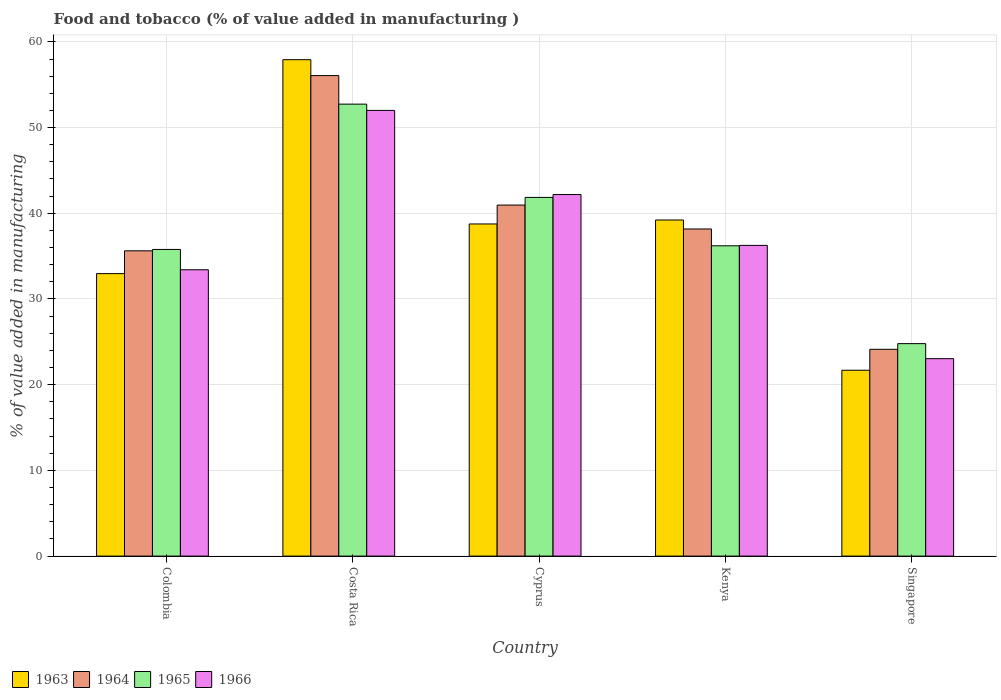How many different coloured bars are there?
Give a very brief answer. 4. Are the number of bars per tick equal to the number of legend labels?
Offer a very short reply. Yes. Are the number of bars on each tick of the X-axis equal?
Your answer should be compact. Yes. How many bars are there on the 1st tick from the left?
Keep it short and to the point. 4. How many bars are there on the 2nd tick from the right?
Ensure brevity in your answer.  4. What is the label of the 5th group of bars from the left?
Your answer should be compact. Singapore. What is the value added in manufacturing food and tobacco in 1965 in Cyprus?
Your response must be concise. 41.85. Across all countries, what is the maximum value added in manufacturing food and tobacco in 1965?
Offer a very short reply. 52.73. Across all countries, what is the minimum value added in manufacturing food and tobacco in 1964?
Ensure brevity in your answer.  24.13. In which country was the value added in manufacturing food and tobacco in 1965 maximum?
Provide a short and direct response. Costa Rica. In which country was the value added in manufacturing food and tobacco in 1965 minimum?
Provide a succinct answer. Singapore. What is the total value added in manufacturing food and tobacco in 1965 in the graph?
Your answer should be very brief. 191.36. What is the difference between the value added in manufacturing food and tobacco in 1964 in Kenya and that in Singapore?
Offer a very short reply. 14.04. What is the difference between the value added in manufacturing food and tobacco in 1964 in Cyprus and the value added in manufacturing food and tobacco in 1963 in Costa Rica?
Ensure brevity in your answer.  -16.96. What is the average value added in manufacturing food and tobacco in 1966 per country?
Ensure brevity in your answer.  37.38. What is the difference between the value added in manufacturing food and tobacco of/in 1965 and value added in manufacturing food and tobacco of/in 1964 in Singapore?
Provide a short and direct response. 0.66. In how many countries, is the value added in manufacturing food and tobacco in 1966 greater than 20 %?
Make the answer very short. 5. What is the ratio of the value added in manufacturing food and tobacco in 1965 in Colombia to that in Singapore?
Provide a short and direct response. 1.44. Is the difference between the value added in manufacturing food and tobacco in 1965 in Costa Rica and Cyprus greater than the difference between the value added in manufacturing food and tobacco in 1964 in Costa Rica and Cyprus?
Your answer should be compact. No. What is the difference between the highest and the second highest value added in manufacturing food and tobacco in 1966?
Make the answer very short. -9.82. What is the difference between the highest and the lowest value added in manufacturing food and tobacco in 1966?
Offer a terse response. 28.97. In how many countries, is the value added in manufacturing food and tobacco in 1963 greater than the average value added in manufacturing food and tobacco in 1963 taken over all countries?
Your answer should be compact. 3. Is the sum of the value added in manufacturing food and tobacco in 1966 in Colombia and Cyprus greater than the maximum value added in manufacturing food and tobacco in 1964 across all countries?
Provide a short and direct response. Yes. What does the 3rd bar from the left in Cyprus represents?
Your answer should be very brief. 1965. What does the 1st bar from the right in Singapore represents?
Your answer should be very brief. 1966. How many bars are there?
Give a very brief answer. 20. How many countries are there in the graph?
Provide a short and direct response. 5. What is the difference between two consecutive major ticks on the Y-axis?
Offer a very short reply. 10. Where does the legend appear in the graph?
Provide a succinct answer. Bottom left. How many legend labels are there?
Your answer should be compact. 4. How are the legend labels stacked?
Give a very brief answer. Horizontal. What is the title of the graph?
Keep it short and to the point. Food and tobacco (% of value added in manufacturing ). Does "2000" appear as one of the legend labels in the graph?
Give a very brief answer. No. What is the label or title of the X-axis?
Your response must be concise. Country. What is the label or title of the Y-axis?
Your answer should be compact. % of value added in manufacturing. What is the % of value added in manufacturing in 1963 in Colombia?
Keep it short and to the point. 32.96. What is the % of value added in manufacturing in 1964 in Colombia?
Make the answer very short. 35.62. What is the % of value added in manufacturing in 1965 in Colombia?
Make the answer very short. 35.78. What is the % of value added in manufacturing of 1966 in Colombia?
Your answer should be compact. 33.41. What is the % of value added in manufacturing of 1963 in Costa Rica?
Your answer should be very brief. 57.92. What is the % of value added in manufacturing in 1964 in Costa Rica?
Your answer should be compact. 56.07. What is the % of value added in manufacturing in 1965 in Costa Rica?
Offer a very short reply. 52.73. What is the % of value added in manufacturing in 1966 in Costa Rica?
Your answer should be very brief. 52. What is the % of value added in manufacturing of 1963 in Cyprus?
Offer a very short reply. 38.75. What is the % of value added in manufacturing of 1964 in Cyprus?
Give a very brief answer. 40.96. What is the % of value added in manufacturing of 1965 in Cyprus?
Offer a very short reply. 41.85. What is the % of value added in manufacturing in 1966 in Cyprus?
Your answer should be very brief. 42.19. What is the % of value added in manufacturing of 1963 in Kenya?
Give a very brief answer. 39.22. What is the % of value added in manufacturing of 1964 in Kenya?
Offer a very short reply. 38.17. What is the % of value added in manufacturing of 1965 in Kenya?
Your answer should be compact. 36.2. What is the % of value added in manufacturing of 1966 in Kenya?
Keep it short and to the point. 36.25. What is the % of value added in manufacturing in 1963 in Singapore?
Provide a short and direct response. 21.69. What is the % of value added in manufacturing in 1964 in Singapore?
Give a very brief answer. 24.13. What is the % of value added in manufacturing of 1965 in Singapore?
Ensure brevity in your answer.  24.79. What is the % of value added in manufacturing in 1966 in Singapore?
Ensure brevity in your answer.  23.04. Across all countries, what is the maximum % of value added in manufacturing of 1963?
Your answer should be very brief. 57.92. Across all countries, what is the maximum % of value added in manufacturing of 1964?
Make the answer very short. 56.07. Across all countries, what is the maximum % of value added in manufacturing of 1965?
Provide a succinct answer. 52.73. Across all countries, what is the maximum % of value added in manufacturing in 1966?
Give a very brief answer. 52. Across all countries, what is the minimum % of value added in manufacturing of 1963?
Your answer should be compact. 21.69. Across all countries, what is the minimum % of value added in manufacturing in 1964?
Ensure brevity in your answer.  24.13. Across all countries, what is the minimum % of value added in manufacturing of 1965?
Your answer should be compact. 24.79. Across all countries, what is the minimum % of value added in manufacturing of 1966?
Give a very brief answer. 23.04. What is the total % of value added in manufacturing in 1963 in the graph?
Make the answer very short. 190.54. What is the total % of value added in manufacturing of 1964 in the graph?
Your response must be concise. 194.94. What is the total % of value added in manufacturing in 1965 in the graph?
Your response must be concise. 191.36. What is the total % of value added in manufacturing of 1966 in the graph?
Give a very brief answer. 186.89. What is the difference between the % of value added in manufacturing in 1963 in Colombia and that in Costa Rica?
Provide a succinct answer. -24.96. What is the difference between the % of value added in manufacturing in 1964 in Colombia and that in Costa Rica?
Offer a terse response. -20.45. What is the difference between the % of value added in manufacturing of 1965 in Colombia and that in Costa Rica?
Your answer should be very brief. -16.95. What is the difference between the % of value added in manufacturing in 1966 in Colombia and that in Costa Rica?
Make the answer very short. -18.59. What is the difference between the % of value added in manufacturing of 1963 in Colombia and that in Cyprus?
Your answer should be very brief. -5.79. What is the difference between the % of value added in manufacturing of 1964 in Colombia and that in Cyprus?
Your response must be concise. -5.34. What is the difference between the % of value added in manufacturing of 1965 in Colombia and that in Cyprus?
Your answer should be compact. -6.07. What is the difference between the % of value added in manufacturing in 1966 in Colombia and that in Cyprus?
Offer a very short reply. -8.78. What is the difference between the % of value added in manufacturing of 1963 in Colombia and that in Kenya?
Keep it short and to the point. -6.26. What is the difference between the % of value added in manufacturing of 1964 in Colombia and that in Kenya?
Provide a short and direct response. -2.55. What is the difference between the % of value added in manufacturing in 1965 in Colombia and that in Kenya?
Provide a short and direct response. -0.42. What is the difference between the % of value added in manufacturing of 1966 in Colombia and that in Kenya?
Ensure brevity in your answer.  -2.84. What is the difference between the % of value added in manufacturing of 1963 in Colombia and that in Singapore?
Offer a very short reply. 11.27. What is the difference between the % of value added in manufacturing of 1964 in Colombia and that in Singapore?
Your answer should be compact. 11.49. What is the difference between the % of value added in manufacturing in 1965 in Colombia and that in Singapore?
Keep it short and to the point. 10.99. What is the difference between the % of value added in manufacturing of 1966 in Colombia and that in Singapore?
Keep it short and to the point. 10.37. What is the difference between the % of value added in manufacturing in 1963 in Costa Rica and that in Cyprus?
Provide a short and direct response. 19.17. What is the difference between the % of value added in manufacturing in 1964 in Costa Rica and that in Cyprus?
Provide a succinct answer. 15.11. What is the difference between the % of value added in manufacturing in 1965 in Costa Rica and that in Cyprus?
Offer a very short reply. 10.88. What is the difference between the % of value added in manufacturing in 1966 in Costa Rica and that in Cyprus?
Your answer should be very brief. 9.82. What is the difference between the % of value added in manufacturing of 1963 in Costa Rica and that in Kenya?
Keep it short and to the point. 18.7. What is the difference between the % of value added in manufacturing in 1964 in Costa Rica and that in Kenya?
Provide a succinct answer. 17.9. What is the difference between the % of value added in manufacturing of 1965 in Costa Rica and that in Kenya?
Provide a short and direct response. 16.53. What is the difference between the % of value added in manufacturing of 1966 in Costa Rica and that in Kenya?
Offer a very short reply. 15.75. What is the difference between the % of value added in manufacturing of 1963 in Costa Rica and that in Singapore?
Provide a short and direct response. 36.23. What is the difference between the % of value added in manufacturing in 1964 in Costa Rica and that in Singapore?
Offer a very short reply. 31.94. What is the difference between the % of value added in manufacturing in 1965 in Costa Rica and that in Singapore?
Your answer should be very brief. 27.94. What is the difference between the % of value added in manufacturing in 1966 in Costa Rica and that in Singapore?
Give a very brief answer. 28.97. What is the difference between the % of value added in manufacturing in 1963 in Cyprus and that in Kenya?
Provide a succinct answer. -0.46. What is the difference between the % of value added in manufacturing in 1964 in Cyprus and that in Kenya?
Ensure brevity in your answer.  2.79. What is the difference between the % of value added in manufacturing in 1965 in Cyprus and that in Kenya?
Ensure brevity in your answer.  5.65. What is the difference between the % of value added in manufacturing of 1966 in Cyprus and that in Kenya?
Provide a succinct answer. 5.93. What is the difference between the % of value added in manufacturing in 1963 in Cyprus and that in Singapore?
Your answer should be very brief. 17.07. What is the difference between the % of value added in manufacturing in 1964 in Cyprus and that in Singapore?
Your response must be concise. 16.83. What is the difference between the % of value added in manufacturing in 1965 in Cyprus and that in Singapore?
Your answer should be compact. 17.06. What is the difference between the % of value added in manufacturing of 1966 in Cyprus and that in Singapore?
Provide a short and direct response. 19.15. What is the difference between the % of value added in manufacturing of 1963 in Kenya and that in Singapore?
Your response must be concise. 17.53. What is the difference between the % of value added in manufacturing in 1964 in Kenya and that in Singapore?
Ensure brevity in your answer.  14.04. What is the difference between the % of value added in manufacturing of 1965 in Kenya and that in Singapore?
Your answer should be very brief. 11.41. What is the difference between the % of value added in manufacturing of 1966 in Kenya and that in Singapore?
Provide a succinct answer. 13.22. What is the difference between the % of value added in manufacturing of 1963 in Colombia and the % of value added in manufacturing of 1964 in Costa Rica?
Your response must be concise. -23.11. What is the difference between the % of value added in manufacturing in 1963 in Colombia and the % of value added in manufacturing in 1965 in Costa Rica?
Make the answer very short. -19.77. What is the difference between the % of value added in manufacturing in 1963 in Colombia and the % of value added in manufacturing in 1966 in Costa Rica?
Keep it short and to the point. -19.04. What is the difference between the % of value added in manufacturing of 1964 in Colombia and the % of value added in manufacturing of 1965 in Costa Rica?
Offer a terse response. -17.11. What is the difference between the % of value added in manufacturing in 1964 in Colombia and the % of value added in manufacturing in 1966 in Costa Rica?
Provide a succinct answer. -16.38. What is the difference between the % of value added in manufacturing of 1965 in Colombia and the % of value added in manufacturing of 1966 in Costa Rica?
Your answer should be compact. -16.22. What is the difference between the % of value added in manufacturing of 1963 in Colombia and the % of value added in manufacturing of 1964 in Cyprus?
Your answer should be very brief. -8. What is the difference between the % of value added in manufacturing in 1963 in Colombia and the % of value added in manufacturing in 1965 in Cyprus?
Your response must be concise. -8.89. What is the difference between the % of value added in manufacturing in 1963 in Colombia and the % of value added in manufacturing in 1966 in Cyprus?
Make the answer very short. -9.23. What is the difference between the % of value added in manufacturing in 1964 in Colombia and the % of value added in manufacturing in 1965 in Cyprus?
Offer a very short reply. -6.23. What is the difference between the % of value added in manufacturing in 1964 in Colombia and the % of value added in manufacturing in 1966 in Cyprus?
Provide a succinct answer. -6.57. What is the difference between the % of value added in manufacturing of 1965 in Colombia and the % of value added in manufacturing of 1966 in Cyprus?
Your answer should be compact. -6.41. What is the difference between the % of value added in manufacturing in 1963 in Colombia and the % of value added in manufacturing in 1964 in Kenya?
Make the answer very short. -5.21. What is the difference between the % of value added in manufacturing of 1963 in Colombia and the % of value added in manufacturing of 1965 in Kenya?
Your answer should be very brief. -3.24. What is the difference between the % of value added in manufacturing of 1963 in Colombia and the % of value added in manufacturing of 1966 in Kenya?
Provide a short and direct response. -3.29. What is the difference between the % of value added in manufacturing of 1964 in Colombia and the % of value added in manufacturing of 1965 in Kenya?
Give a very brief answer. -0.58. What is the difference between the % of value added in manufacturing in 1964 in Colombia and the % of value added in manufacturing in 1966 in Kenya?
Make the answer very short. -0.63. What is the difference between the % of value added in manufacturing of 1965 in Colombia and the % of value added in manufacturing of 1966 in Kenya?
Provide a succinct answer. -0.47. What is the difference between the % of value added in manufacturing of 1963 in Colombia and the % of value added in manufacturing of 1964 in Singapore?
Keep it short and to the point. 8.83. What is the difference between the % of value added in manufacturing of 1963 in Colombia and the % of value added in manufacturing of 1965 in Singapore?
Your response must be concise. 8.17. What is the difference between the % of value added in manufacturing in 1963 in Colombia and the % of value added in manufacturing in 1966 in Singapore?
Give a very brief answer. 9.92. What is the difference between the % of value added in manufacturing of 1964 in Colombia and the % of value added in manufacturing of 1965 in Singapore?
Keep it short and to the point. 10.83. What is the difference between the % of value added in manufacturing of 1964 in Colombia and the % of value added in manufacturing of 1966 in Singapore?
Your answer should be very brief. 12.58. What is the difference between the % of value added in manufacturing in 1965 in Colombia and the % of value added in manufacturing in 1966 in Singapore?
Give a very brief answer. 12.74. What is the difference between the % of value added in manufacturing in 1963 in Costa Rica and the % of value added in manufacturing in 1964 in Cyprus?
Your answer should be very brief. 16.96. What is the difference between the % of value added in manufacturing of 1963 in Costa Rica and the % of value added in manufacturing of 1965 in Cyprus?
Offer a very short reply. 16.07. What is the difference between the % of value added in manufacturing of 1963 in Costa Rica and the % of value added in manufacturing of 1966 in Cyprus?
Your answer should be very brief. 15.73. What is the difference between the % of value added in manufacturing in 1964 in Costa Rica and the % of value added in manufacturing in 1965 in Cyprus?
Give a very brief answer. 14.21. What is the difference between the % of value added in manufacturing of 1964 in Costa Rica and the % of value added in manufacturing of 1966 in Cyprus?
Your answer should be very brief. 13.88. What is the difference between the % of value added in manufacturing of 1965 in Costa Rica and the % of value added in manufacturing of 1966 in Cyprus?
Offer a very short reply. 10.55. What is the difference between the % of value added in manufacturing of 1963 in Costa Rica and the % of value added in manufacturing of 1964 in Kenya?
Offer a terse response. 19.75. What is the difference between the % of value added in manufacturing in 1963 in Costa Rica and the % of value added in manufacturing in 1965 in Kenya?
Make the answer very short. 21.72. What is the difference between the % of value added in manufacturing of 1963 in Costa Rica and the % of value added in manufacturing of 1966 in Kenya?
Offer a terse response. 21.67. What is the difference between the % of value added in manufacturing of 1964 in Costa Rica and the % of value added in manufacturing of 1965 in Kenya?
Offer a very short reply. 19.86. What is the difference between the % of value added in manufacturing of 1964 in Costa Rica and the % of value added in manufacturing of 1966 in Kenya?
Your answer should be very brief. 19.81. What is the difference between the % of value added in manufacturing of 1965 in Costa Rica and the % of value added in manufacturing of 1966 in Kenya?
Your answer should be compact. 16.48. What is the difference between the % of value added in manufacturing in 1963 in Costa Rica and the % of value added in manufacturing in 1964 in Singapore?
Your response must be concise. 33.79. What is the difference between the % of value added in manufacturing in 1963 in Costa Rica and the % of value added in manufacturing in 1965 in Singapore?
Keep it short and to the point. 33.13. What is the difference between the % of value added in manufacturing in 1963 in Costa Rica and the % of value added in manufacturing in 1966 in Singapore?
Keep it short and to the point. 34.88. What is the difference between the % of value added in manufacturing of 1964 in Costa Rica and the % of value added in manufacturing of 1965 in Singapore?
Provide a short and direct response. 31.28. What is the difference between the % of value added in manufacturing of 1964 in Costa Rica and the % of value added in manufacturing of 1966 in Singapore?
Offer a terse response. 33.03. What is the difference between the % of value added in manufacturing in 1965 in Costa Rica and the % of value added in manufacturing in 1966 in Singapore?
Your response must be concise. 29.7. What is the difference between the % of value added in manufacturing of 1963 in Cyprus and the % of value added in manufacturing of 1964 in Kenya?
Your answer should be very brief. 0.59. What is the difference between the % of value added in manufacturing of 1963 in Cyprus and the % of value added in manufacturing of 1965 in Kenya?
Ensure brevity in your answer.  2.55. What is the difference between the % of value added in manufacturing of 1963 in Cyprus and the % of value added in manufacturing of 1966 in Kenya?
Your response must be concise. 2.5. What is the difference between the % of value added in manufacturing of 1964 in Cyprus and the % of value added in manufacturing of 1965 in Kenya?
Keep it short and to the point. 4.75. What is the difference between the % of value added in manufacturing in 1964 in Cyprus and the % of value added in manufacturing in 1966 in Kenya?
Your response must be concise. 4.7. What is the difference between the % of value added in manufacturing of 1965 in Cyprus and the % of value added in manufacturing of 1966 in Kenya?
Keep it short and to the point. 5.6. What is the difference between the % of value added in manufacturing of 1963 in Cyprus and the % of value added in manufacturing of 1964 in Singapore?
Provide a succinct answer. 14.63. What is the difference between the % of value added in manufacturing in 1963 in Cyprus and the % of value added in manufacturing in 1965 in Singapore?
Provide a short and direct response. 13.96. What is the difference between the % of value added in manufacturing in 1963 in Cyprus and the % of value added in manufacturing in 1966 in Singapore?
Offer a very short reply. 15.72. What is the difference between the % of value added in manufacturing in 1964 in Cyprus and the % of value added in manufacturing in 1965 in Singapore?
Provide a short and direct response. 16.17. What is the difference between the % of value added in manufacturing of 1964 in Cyprus and the % of value added in manufacturing of 1966 in Singapore?
Give a very brief answer. 17.92. What is the difference between the % of value added in manufacturing in 1965 in Cyprus and the % of value added in manufacturing in 1966 in Singapore?
Your answer should be very brief. 18.82. What is the difference between the % of value added in manufacturing of 1963 in Kenya and the % of value added in manufacturing of 1964 in Singapore?
Keep it short and to the point. 15.09. What is the difference between the % of value added in manufacturing of 1963 in Kenya and the % of value added in manufacturing of 1965 in Singapore?
Ensure brevity in your answer.  14.43. What is the difference between the % of value added in manufacturing of 1963 in Kenya and the % of value added in manufacturing of 1966 in Singapore?
Provide a succinct answer. 16.18. What is the difference between the % of value added in manufacturing of 1964 in Kenya and the % of value added in manufacturing of 1965 in Singapore?
Your response must be concise. 13.38. What is the difference between the % of value added in manufacturing in 1964 in Kenya and the % of value added in manufacturing in 1966 in Singapore?
Offer a very short reply. 15.13. What is the difference between the % of value added in manufacturing in 1965 in Kenya and the % of value added in manufacturing in 1966 in Singapore?
Make the answer very short. 13.17. What is the average % of value added in manufacturing in 1963 per country?
Your answer should be very brief. 38.11. What is the average % of value added in manufacturing in 1964 per country?
Your answer should be very brief. 38.99. What is the average % of value added in manufacturing in 1965 per country?
Offer a very short reply. 38.27. What is the average % of value added in manufacturing in 1966 per country?
Offer a terse response. 37.38. What is the difference between the % of value added in manufacturing in 1963 and % of value added in manufacturing in 1964 in Colombia?
Offer a terse response. -2.66. What is the difference between the % of value added in manufacturing in 1963 and % of value added in manufacturing in 1965 in Colombia?
Offer a terse response. -2.82. What is the difference between the % of value added in manufacturing of 1963 and % of value added in manufacturing of 1966 in Colombia?
Make the answer very short. -0.45. What is the difference between the % of value added in manufacturing in 1964 and % of value added in manufacturing in 1965 in Colombia?
Offer a very short reply. -0.16. What is the difference between the % of value added in manufacturing of 1964 and % of value added in manufacturing of 1966 in Colombia?
Offer a terse response. 2.21. What is the difference between the % of value added in manufacturing in 1965 and % of value added in manufacturing in 1966 in Colombia?
Your answer should be very brief. 2.37. What is the difference between the % of value added in manufacturing in 1963 and % of value added in manufacturing in 1964 in Costa Rica?
Make the answer very short. 1.85. What is the difference between the % of value added in manufacturing of 1963 and % of value added in manufacturing of 1965 in Costa Rica?
Offer a very short reply. 5.19. What is the difference between the % of value added in manufacturing of 1963 and % of value added in manufacturing of 1966 in Costa Rica?
Ensure brevity in your answer.  5.92. What is the difference between the % of value added in manufacturing in 1964 and % of value added in manufacturing in 1965 in Costa Rica?
Keep it short and to the point. 3.33. What is the difference between the % of value added in manufacturing of 1964 and % of value added in manufacturing of 1966 in Costa Rica?
Provide a short and direct response. 4.06. What is the difference between the % of value added in manufacturing in 1965 and % of value added in manufacturing in 1966 in Costa Rica?
Provide a short and direct response. 0.73. What is the difference between the % of value added in manufacturing in 1963 and % of value added in manufacturing in 1964 in Cyprus?
Give a very brief answer. -2.2. What is the difference between the % of value added in manufacturing in 1963 and % of value added in manufacturing in 1965 in Cyprus?
Keep it short and to the point. -3.1. What is the difference between the % of value added in manufacturing in 1963 and % of value added in manufacturing in 1966 in Cyprus?
Make the answer very short. -3.43. What is the difference between the % of value added in manufacturing in 1964 and % of value added in manufacturing in 1965 in Cyprus?
Your response must be concise. -0.9. What is the difference between the % of value added in manufacturing in 1964 and % of value added in manufacturing in 1966 in Cyprus?
Your answer should be compact. -1.23. What is the difference between the % of value added in manufacturing of 1965 and % of value added in manufacturing of 1966 in Cyprus?
Your answer should be very brief. -0.33. What is the difference between the % of value added in manufacturing in 1963 and % of value added in manufacturing in 1964 in Kenya?
Provide a succinct answer. 1.05. What is the difference between the % of value added in manufacturing in 1963 and % of value added in manufacturing in 1965 in Kenya?
Your answer should be compact. 3.01. What is the difference between the % of value added in manufacturing of 1963 and % of value added in manufacturing of 1966 in Kenya?
Your response must be concise. 2.96. What is the difference between the % of value added in manufacturing in 1964 and % of value added in manufacturing in 1965 in Kenya?
Keep it short and to the point. 1.96. What is the difference between the % of value added in manufacturing of 1964 and % of value added in manufacturing of 1966 in Kenya?
Keep it short and to the point. 1.91. What is the difference between the % of value added in manufacturing of 1965 and % of value added in manufacturing of 1966 in Kenya?
Offer a terse response. -0.05. What is the difference between the % of value added in manufacturing in 1963 and % of value added in manufacturing in 1964 in Singapore?
Offer a terse response. -2.44. What is the difference between the % of value added in manufacturing in 1963 and % of value added in manufacturing in 1965 in Singapore?
Offer a terse response. -3.1. What is the difference between the % of value added in manufacturing of 1963 and % of value added in manufacturing of 1966 in Singapore?
Your answer should be very brief. -1.35. What is the difference between the % of value added in manufacturing of 1964 and % of value added in manufacturing of 1965 in Singapore?
Keep it short and to the point. -0.66. What is the difference between the % of value added in manufacturing of 1964 and % of value added in manufacturing of 1966 in Singapore?
Provide a succinct answer. 1.09. What is the difference between the % of value added in manufacturing in 1965 and % of value added in manufacturing in 1966 in Singapore?
Offer a terse response. 1.75. What is the ratio of the % of value added in manufacturing of 1963 in Colombia to that in Costa Rica?
Your answer should be very brief. 0.57. What is the ratio of the % of value added in manufacturing of 1964 in Colombia to that in Costa Rica?
Make the answer very short. 0.64. What is the ratio of the % of value added in manufacturing of 1965 in Colombia to that in Costa Rica?
Offer a terse response. 0.68. What is the ratio of the % of value added in manufacturing in 1966 in Colombia to that in Costa Rica?
Make the answer very short. 0.64. What is the ratio of the % of value added in manufacturing in 1963 in Colombia to that in Cyprus?
Ensure brevity in your answer.  0.85. What is the ratio of the % of value added in manufacturing in 1964 in Colombia to that in Cyprus?
Ensure brevity in your answer.  0.87. What is the ratio of the % of value added in manufacturing in 1965 in Colombia to that in Cyprus?
Provide a succinct answer. 0.85. What is the ratio of the % of value added in manufacturing in 1966 in Colombia to that in Cyprus?
Offer a very short reply. 0.79. What is the ratio of the % of value added in manufacturing of 1963 in Colombia to that in Kenya?
Provide a succinct answer. 0.84. What is the ratio of the % of value added in manufacturing in 1964 in Colombia to that in Kenya?
Provide a short and direct response. 0.93. What is the ratio of the % of value added in manufacturing in 1965 in Colombia to that in Kenya?
Your response must be concise. 0.99. What is the ratio of the % of value added in manufacturing of 1966 in Colombia to that in Kenya?
Provide a succinct answer. 0.92. What is the ratio of the % of value added in manufacturing in 1963 in Colombia to that in Singapore?
Provide a short and direct response. 1.52. What is the ratio of the % of value added in manufacturing of 1964 in Colombia to that in Singapore?
Ensure brevity in your answer.  1.48. What is the ratio of the % of value added in manufacturing in 1965 in Colombia to that in Singapore?
Offer a terse response. 1.44. What is the ratio of the % of value added in manufacturing in 1966 in Colombia to that in Singapore?
Offer a very short reply. 1.45. What is the ratio of the % of value added in manufacturing of 1963 in Costa Rica to that in Cyprus?
Ensure brevity in your answer.  1.49. What is the ratio of the % of value added in manufacturing in 1964 in Costa Rica to that in Cyprus?
Provide a succinct answer. 1.37. What is the ratio of the % of value added in manufacturing of 1965 in Costa Rica to that in Cyprus?
Make the answer very short. 1.26. What is the ratio of the % of value added in manufacturing of 1966 in Costa Rica to that in Cyprus?
Make the answer very short. 1.23. What is the ratio of the % of value added in manufacturing of 1963 in Costa Rica to that in Kenya?
Offer a very short reply. 1.48. What is the ratio of the % of value added in manufacturing in 1964 in Costa Rica to that in Kenya?
Your answer should be very brief. 1.47. What is the ratio of the % of value added in manufacturing in 1965 in Costa Rica to that in Kenya?
Give a very brief answer. 1.46. What is the ratio of the % of value added in manufacturing in 1966 in Costa Rica to that in Kenya?
Offer a terse response. 1.43. What is the ratio of the % of value added in manufacturing in 1963 in Costa Rica to that in Singapore?
Make the answer very short. 2.67. What is the ratio of the % of value added in manufacturing of 1964 in Costa Rica to that in Singapore?
Make the answer very short. 2.32. What is the ratio of the % of value added in manufacturing in 1965 in Costa Rica to that in Singapore?
Offer a terse response. 2.13. What is the ratio of the % of value added in manufacturing in 1966 in Costa Rica to that in Singapore?
Provide a succinct answer. 2.26. What is the ratio of the % of value added in manufacturing in 1963 in Cyprus to that in Kenya?
Offer a very short reply. 0.99. What is the ratio of the % of value added in manufacturing in 1964 in Cyprus to that in Kenya?
Provide a short and direct response. 1.07. What is the ratio of the % of value added in manufacturing of 1965 in Cyprus to that in Kenya?
Ensure brevity in your answer.  1.16. What is the ratio of the % of value added in manufacturing in 1966 in Cyprus to that in Kenya?
Give a very brief answer. 1.16. What is the ratio of the % of value added in manufacturing of 1963 in Cyprus to that in Singapore?
Offer a terse response. 1.79. What is the ratio of the % of value added in manufacturing in 1964 in Cyprus to that in Singapore?
Your response must be concise. 1.7. What is the ratio of the % of value added in manufacturing in 1965 in Cyprus to that in Singapore?
Offer a very short reply. 1.69. What is the ratio of the % of value added in manufacturing in 1966 in Cyprus to that in Singapore?
Provide a short and direct response. 1.83. What is the ratio of the % of value added in manufacturing in 1963 in Kenya to that in Singapore?
Your answer should be compact. 1.81. What is the ratio of the % of value added in manufacturing of 1964 in Kenya to that in Singapore?
Make the answer very short. 1.58. What is the ratio of the % of value added in manufacturing of 1965 in Kenya to that in Singapore?
Provide a short and direct response. 1.46. What is the ratio of the % of value added in manufacturing of 1966 in Kenya to that in Singapore?
Provide a short and direct response. 1.57. What is the difference between the highest and the second highest % of value added in manufacturing of 1963?
Provide a succinct answer. 18.7. What is the difference between the highest and the second highest % of value added in manufacturing of 1964?
Provide a short and direct response. 15.11. What is the difference between the highest and the second highest % of value added in manufacturing in 1965?
Keep it short and to the point. 10.88. What is the difference between the highest and the second highest % of value added in manufacturing in 1966?
Offer a very short reply. 9.82. What is the difference between the highest and the lowest % of value added in manufacturing in 1963?
Offer a terse response. 36.23. What is the difference between the highest and the lowest % of value added in manufacturing in 1964?
Your response must be concise. 31.94. What is the difference between the highest and the lowest % of value added in manufacturing of 1965?
Your answer should be very brief. 27.94. What is the difference between the highest and the lowest % of value added in manufacturing in 1966?
Keep it short and to the point. 28.97. 